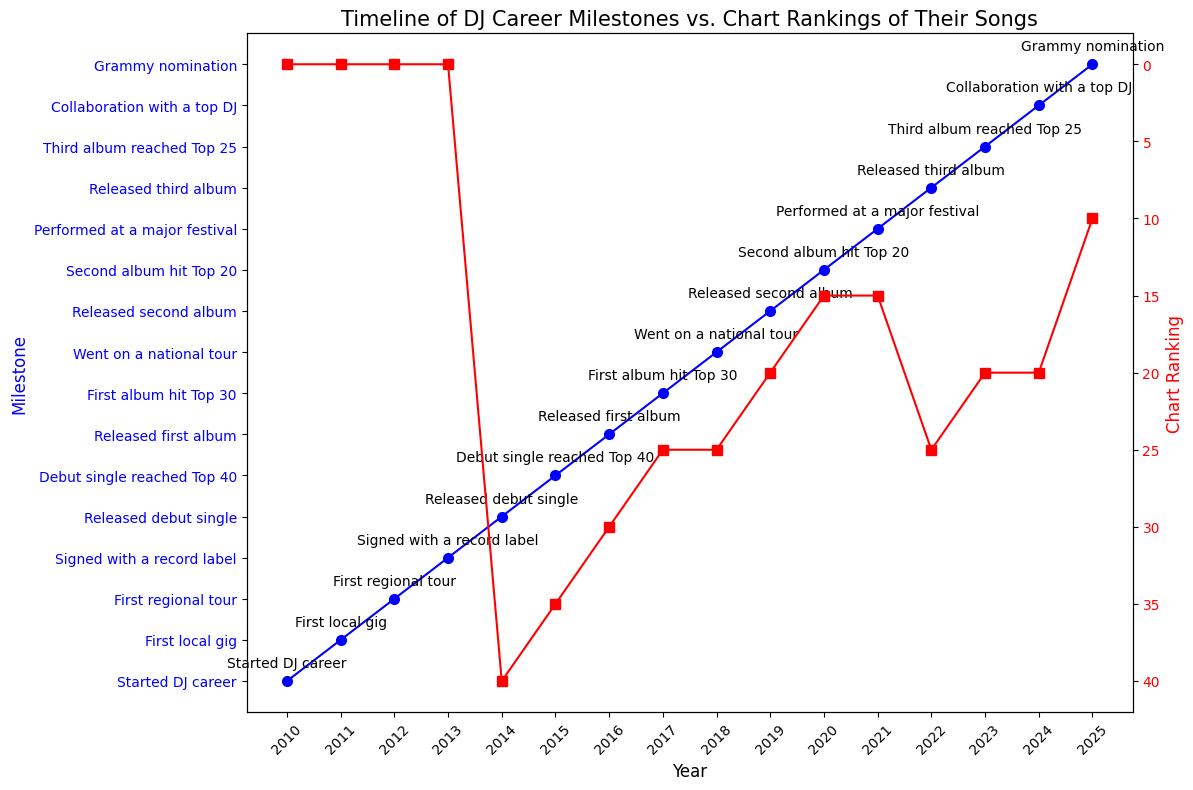What year did the DJ's debut single reach the Top 40? The debut single reached the Top 40 in year 2015, as indicated by the milestone data annotation on the plot.
Answer: 2015 During which year did the DJ sign with a record label and what was their chart ranking that year? In 2013, the DJ signed with a record label; the chart ranking was 0 because the debut single had not been released yet. This is shown at the year 2013 on the milestone data line and the red chart ranking line.
Answer: 2013, 0 What is the difference in chart rankings between the DJ's first album and third album releases? The first album was released in 2016 with a ranking of 30, and the third album was released in 2022 with a ranking of 25. The difference is 30 - 25.
Answer: 5 How many years did it take for the DJ to receive a Grammy nomination from the start of their career? The DJ started their career in 2010 and received a Grammy nomination in 2025, which is 2025 - 2010 = 15 years. This information is shown in the annotated milestones along the timeline.
Answer: 15 years Compare the chart ranking of the DJ’s second album to their first album when they reached their highest ranking. The DJ’s second album, released in 2019, had a ranking of 20, and their highest ranking for the first album was 25 in 2017. Comparing these values shows that the second album had a better ranking.
Answer: Second album had a better ranking What trend can be observed in the DJ’s chart rankings after their debut single reached Top 40? The debut single reached the Top 40 in 2015 at a ranking of 35. Subsequently, the chart rankings improved to 30 for the first album in 2016, 25 for the first album peak in 2017, 20 for the second album in 2019, and 15 for the second album peak in 2020. The trend shows an overall improvement in rankings over time.
Answer: Overall improvement What is the average chart ranking of the DJ's singles and albums from 2014 to 2024? Summing chart rankings from 2014 (40), 2015 (35), 2016 (30), 2017 (25), 2019 (20), 2020 (15), 2022 (25), and 2024 (20) gives 210. Over these 8 years, the average is 210 / 8.
Answer: 26.25 Which milestone coincides with the DJ’s chart ranking peaking at its highest? The DJ’s chart ranking peaked at its highest, 10, in 2025. This coincides with their Grammy nomination milestone. This milestone is clearly annotated next to the year 2025 on the timeline and chart ranking.
Answer: Grammy nomination 